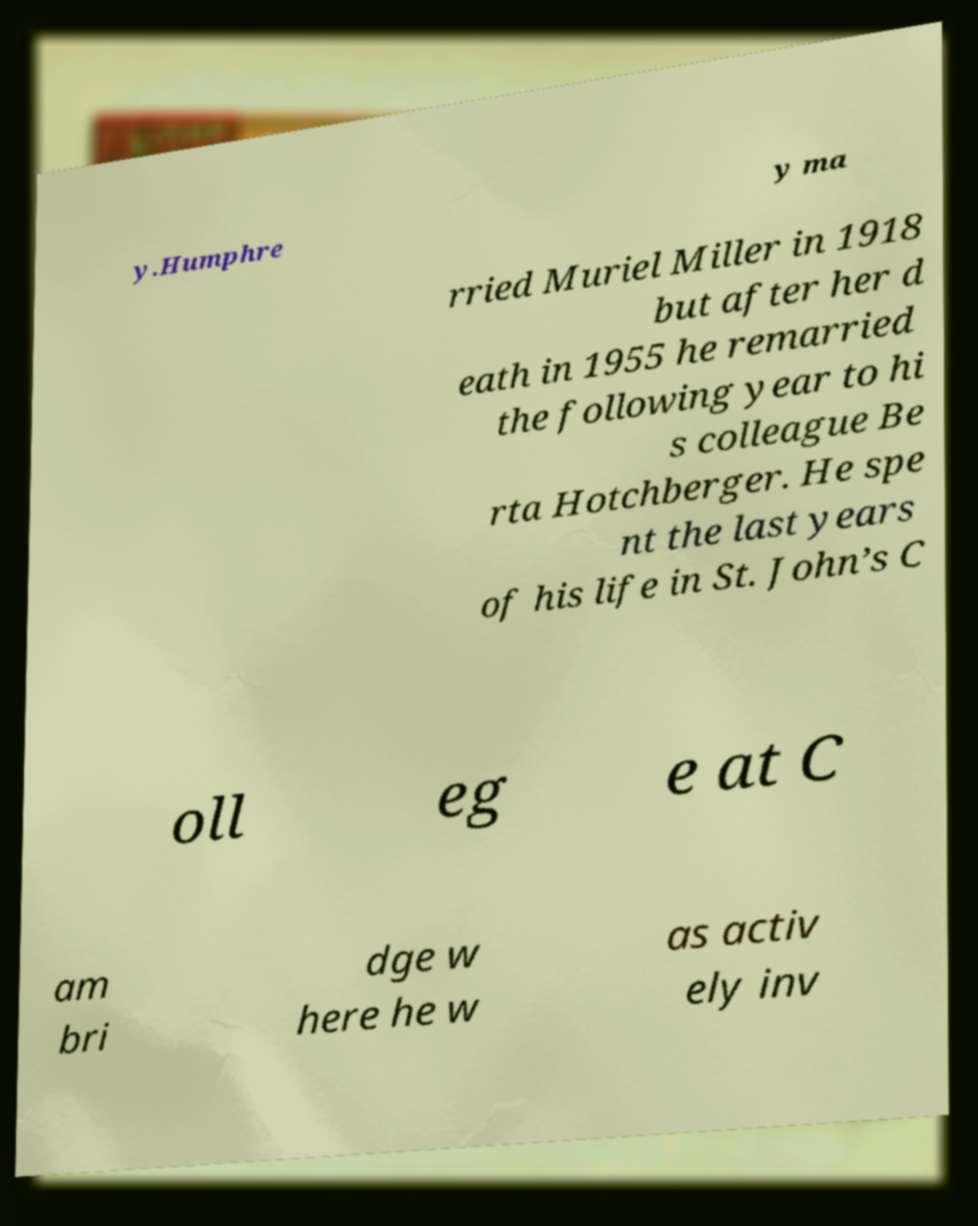For documentation purposes, I need the text within this image transcribed. Could you provide that? y.Humphre y ma rried Muriel Miller in 1918 but after her d eath in 1955 he remarried the following year to hi s colleague Be rta Hotchberger. He spe nt the last years of his life in St. John’s C oll eg e at C am bri dge w here he w as activ ely inv 